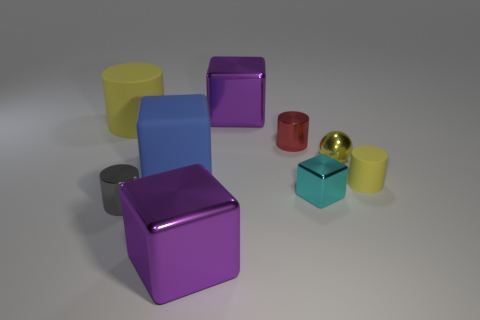Subtract all tiny yellow cylinders. How many cylinders are left? 3 Subtract 2 blocks. How many blocks are left? 2 Subtract all yellow cylinders. How many cylinders are left? 2 Subtract all cylinders. How many objects are left? 5 Subtract all cyan spheres. How many cyan cubes are left? 1 Subtract all big yellow objects. Subtract all tiny metal objects. How many objects are left? 4 Add 1 tiny gray cylinders. How many tiny gray cylinders are left? 2 Add 8 small purple shiny balls. How many small purple shiny balls exist? 8 Subtract 0 purple cylinders. How many objects are left? 9 Subtract all purple balls. Subtract all gray cubes. How many balls are left? 1 